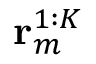Convert formula to latex. <formula><loc_0><loc_0><loc_500><loc_500>r _ { m } ^ { 1 \colon K }</formula> 